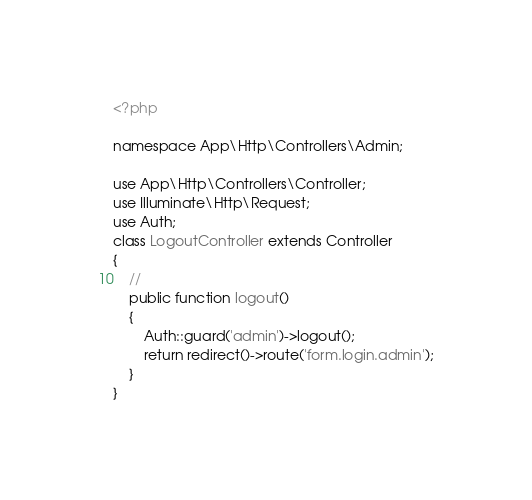Convert code to text. <code><loc_0><loc_0><loc_500><loc_500><_PHP_><?php

namespace App\Http\Controllers\Admin;

use App\Http\Controllers\Controller;
use Illuminate\Http\Request;
use Auth;
class LogoutController extends Controller
{
    //
    public function logout()
    {
        Auth::guard('admin')->logout();
        return redirect()->route('form.login.admin');
    }
}
</code> 